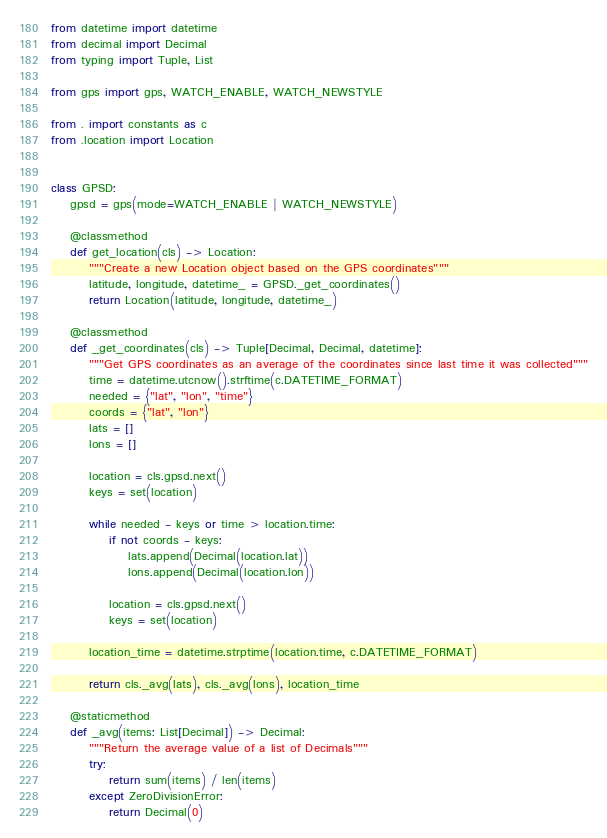<code> <loc_0><loc_0><loc_500><loc_500><_Python_>from datetime import datetime
from decimal import Decimal
from typing import Tuple, List

from gps import gps, WATCH_ENABLE, WATCH_NEWSTYLE

from . import constants as c
from .location import Location


class GPSD:
    gpsd = gps(mode=WATCH_ENABLE | WATCH_NEWSTYLE)

    @classmethod
    def get_location(cls) -> Location:
        """Create a new Location object based on the GPS coordinates"""
        latitude, longitude, datetime_ = GPSD._get_coordinates()
        return Location(latitude, longitude, datetime_)

    @classmethod
    def _get_coordinates(cls) -> Tuple[Decimal, Decimal, datetime]:
        """Get GPS coordinates as an average of the coordinates since last time it was collected"""
        time = datetime.utcnow().strftime(c.DATETIME_FORMAT)
        needed = {"lat", "lon", "time"}
        coords = {"lat", "lon"}
        lats = []
        lons = []

        location = cls.gpsd.next()
        keys = set(location)

        while needed - keys or time > location.time:
            if not coords - keys:
                lats.append(Decimal(location.lat))
                lons.append(Decimal(location.lon))

            location = cls.gpsd.next()
            keys = set(location)

        location_time = datetime.strptime(location.time, c.DATETIME_FORMAT)

        return cls._avg(lats), cls._avg(lons), location_time

    @staticmethod
    def _avg(items: List[Decimal]) -> Decimal:
        """Return the average value of a list of Decimals"""
        try:
            return sum(items) / len(items)
        except ZeroDivisionError:
            return Decimal(0)
</code> 